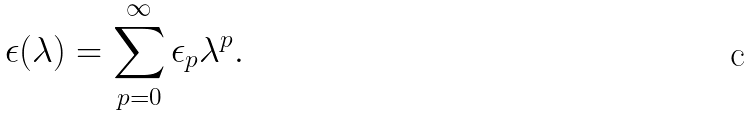<formula> <loc_0><loc_0><loc_500><loc_500>\epsilon ( \lambda ) = \sum _ { p = 0 } ^ { \infty } \epsilon _ { p } \lambda ^ { p } .</formula> 